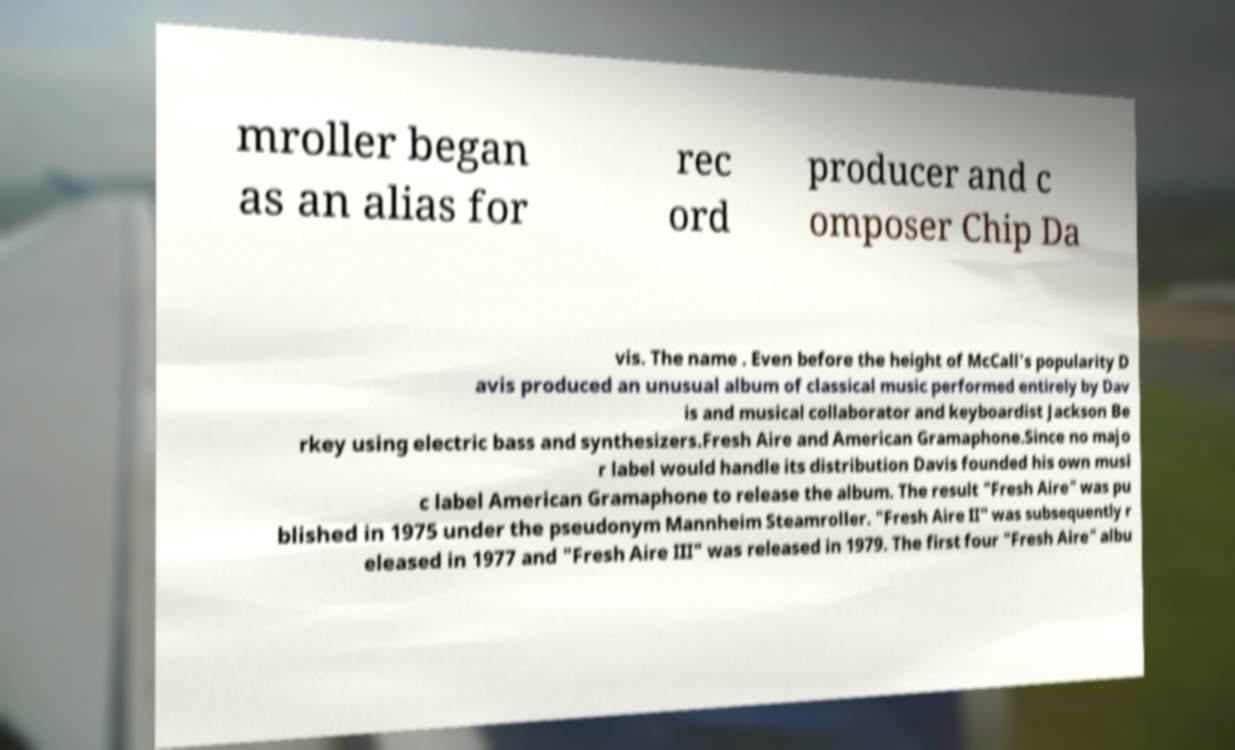Please identify and transcribe the text found in this image. mroller began as an alias for rec ord producer and c omposer Chip Da vis. The name . Even before the height of McCall's popularity D avis produced an unusual album of classical music performed entirely by Dav is and musical collaborator and keyboardist Jackson Be rkey using electric bass and synthesizers.Fresh Aire and American Gramaphone.Since no majo r label would handle its distribution Davis founded his own musi c label American Gramaphone to release the album. The result "Fresh Aire" was pu blished in 1975 under the pseudonym Mannheim Steamroller. "Fresh Aire II" was subsequently r eleased in 1977 and "Fresh Aire III" was released in 1979. The first four "Fresh Aire" albu 